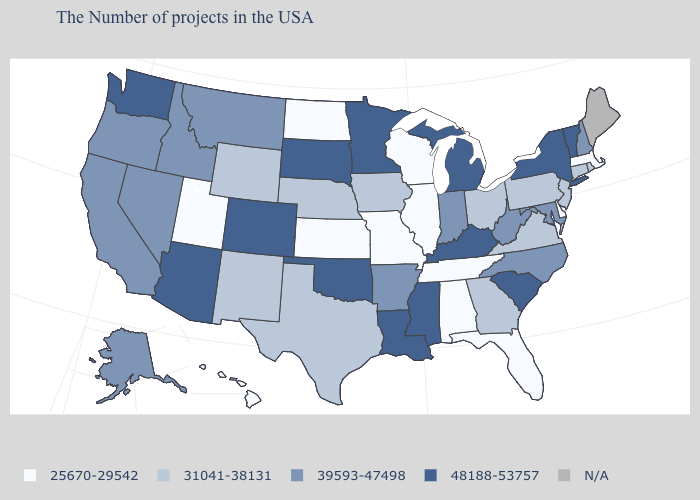Which states hav the highest value in the West?
Give a very brief answer. Colorado, Arizona, Washington. Name the states that have a value in the range N/A?
Keep it brief. Maine. What is the value of Pennsylvania?
Write a very short answer. 31041-38131. What is the value of New Jersey?
Be succinct. 31041-38131. What is the value of Oklahoma?
Concise answer only. 48188-53757. Among the states that border Connecticut , does New York have the lowest value?
Quick response, please. No. Does the first symbol in the legend represent the smallest category?
Short answer required. Yes. What is the highest value in states that border Rhode Island?
Write a very short answer. 31041-38131. Name the states that have a value in the range 31041-38131?
Give a very brief answer. Rhode Island, Connecticut, New Jersey, Pennsylvania, Virginia, Ohio, Georgia, Iowa, Nebraska, Texas, Wyoming, New Mexico. Does Maryland have the lowest value in the USA?
Be succinct. No. Does Michigan have the highest value in the USA?
Be succinct. Yes. Does New York have the highest value in the USA?
Short answer required. Yes. Among the states that border Tennessee , does Georgia have the lowest value?
Give a very brief answer. No. Does Connecticut have the highest value in the Northeast?
Answer briefly. No. Among the states that border Oregon , does California have the highest value?
Give a very brief answer. No. 